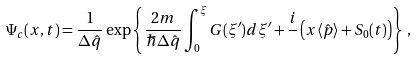<formula> <loc_0><loc_0><loc_500><loc_500>\Psi _ { c } ( x , t ) = \frac { 1 } { \Delta \hat { q } } \exp \left \{ \frac { 2 m } { \hbar { \Delta } \hat { q } } \int _ { 0 } ^ { \xi } G ( \xi ^ { \prime } ) d \xi ^ { \prime } + \frac { i } { } \left ( x \langle \hat { p } \rangle + S _ { 0 } ( t ) \right ) \right \} \, ,</formula> 